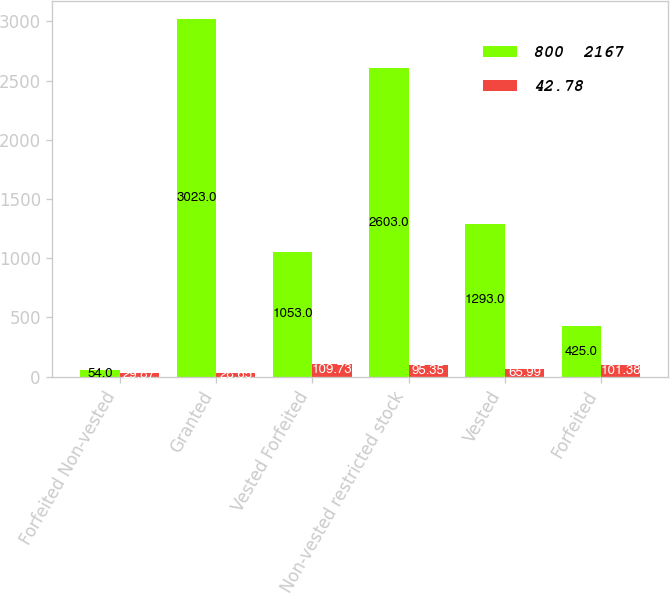Convert chart to OTSL. <chart><loc_0><loc_0><loc_500><loc_500><stacked_bar_chart><ecel><fcel>Forfeited Non-vested<fcel>Granted<fcel>Vested Forfeited<fcel>Non-vested restricted stock<fcel>Vested<fcel>Forfeited<nl><fcel>800  2167<fcel>54<fcel>3023<fcel>1053<fcel>2603<fcel>1293<fcel>425<nl><fcel>42.78<fcel>29.87<fcel>28.65<fcel>109.73<fcel>95.35<fcel>65.99<fcel>101.38<nl></chart> 